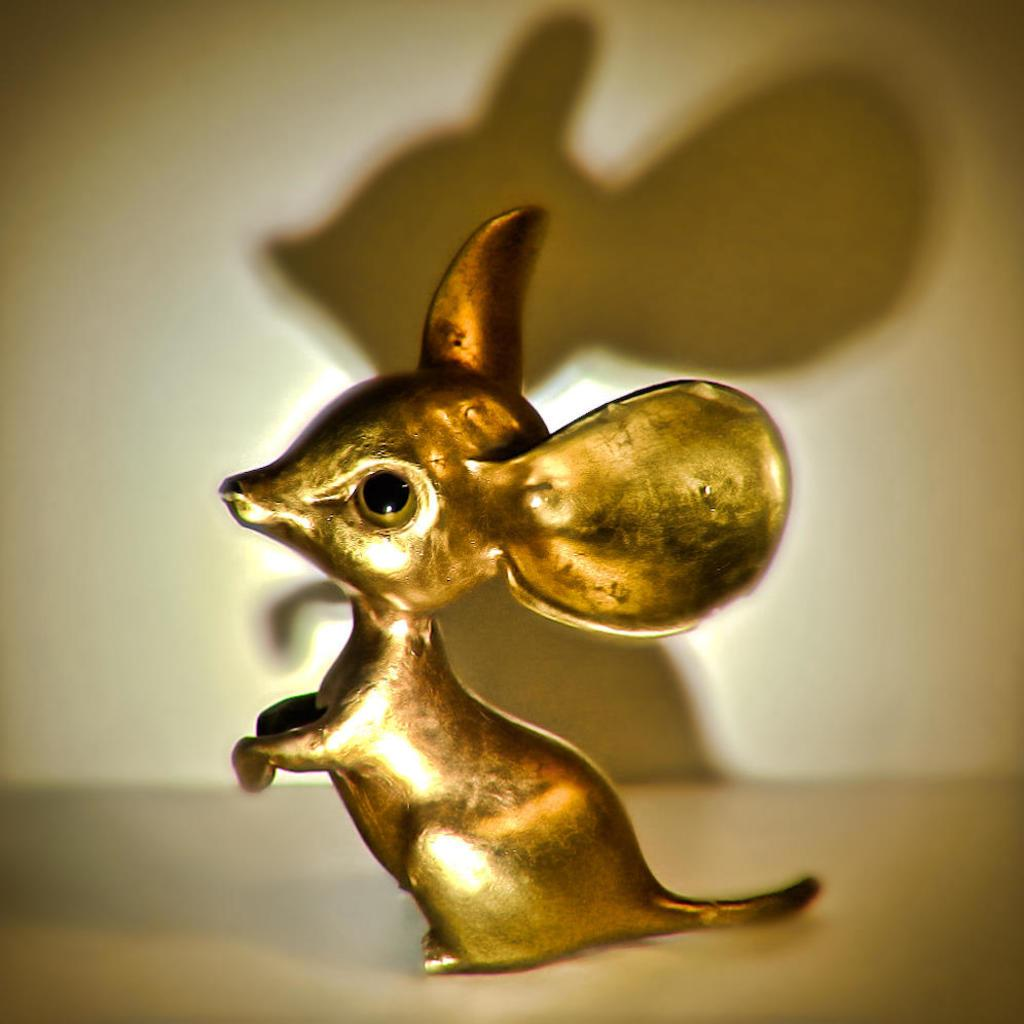What is the main subject in the center of the image? There is a bronze sculpture in the center of the image. What can be seen on the wall in the background of the image? There is a shadow on the wall in the background of the image. What part of the room is visible at the bottom of the image? The floor is visible at the bottom of the image. What type of furniture is present in the wilderness depicted in the image? There is no furniture or wilderness depicted in the image; it features a bronze sculpture, a shadow on the wall, and a visible floor. 